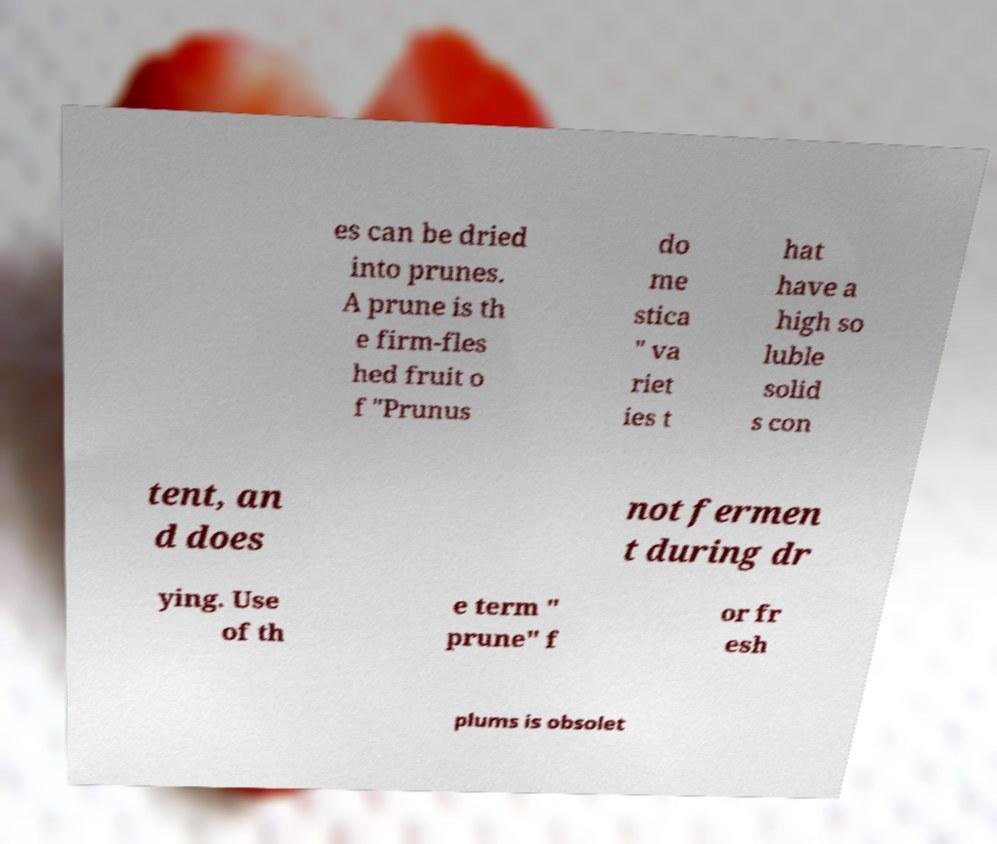I need the written content from this picture converted into text. Can you do that? es can be dried into prunes. A prune is th e firm-fles hed fruit o f "Prunus do me stica " va riet ies t hat have a high so luble solid s con tent, an d does not fermen t during dr ying. Use of th e term " prune" f or fr esh plums is obsolet 